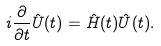<formula> <loc_0><loc_0><loc_500><loc_500>i \frac { \partial } { \partial t } \hat { U } ( t ) = \hat { H } ( t ) \hat { U } ( t ) .</formula> 